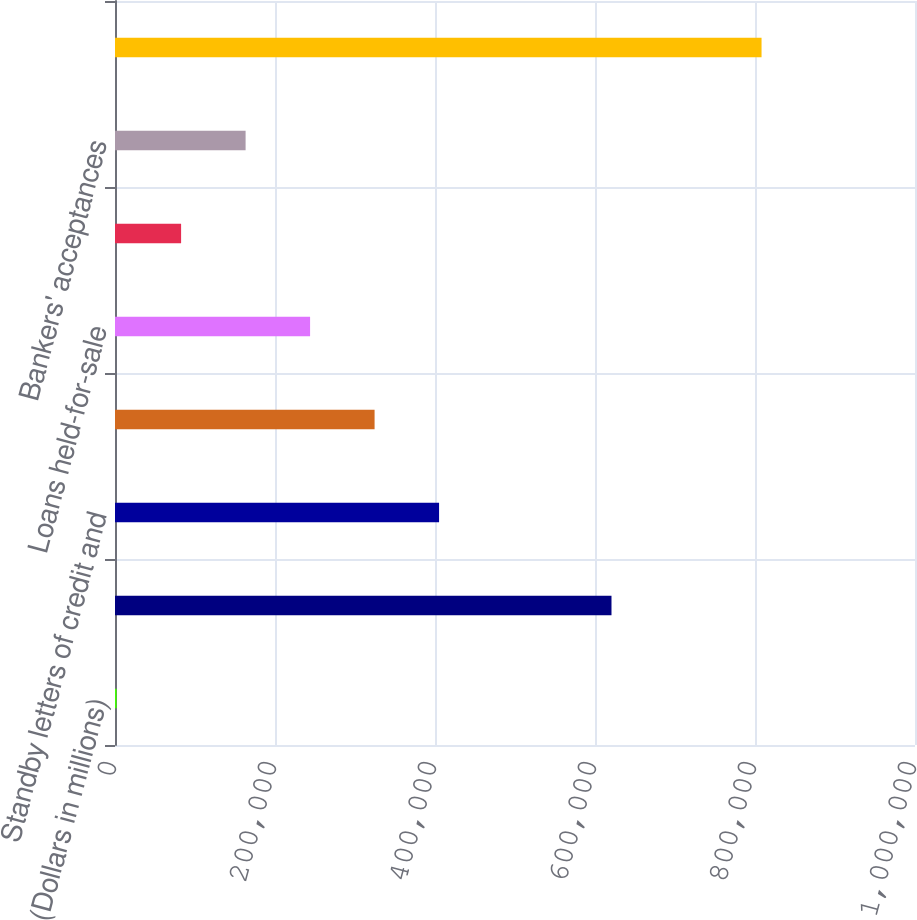Convert chart. <chart><loc_0><loc_0><loc_500><loc_500><bar_chart><fcel>(Dollars in millions)<fcel>Loans and leases<fcel>Standby letters of credit and<fcel>Debt securities and other<fcel>Loans held-for-sale<fcel>Commercial letters of credit<fcel>Bankers' acceptances<fcel>Total commercial credit<nl><fcel>2009<fcel>620612<fcel>405098<fcel>324480<fcel>243862<fcel>82626.7<fcel>163244<fcel>808186<nl></chart> 